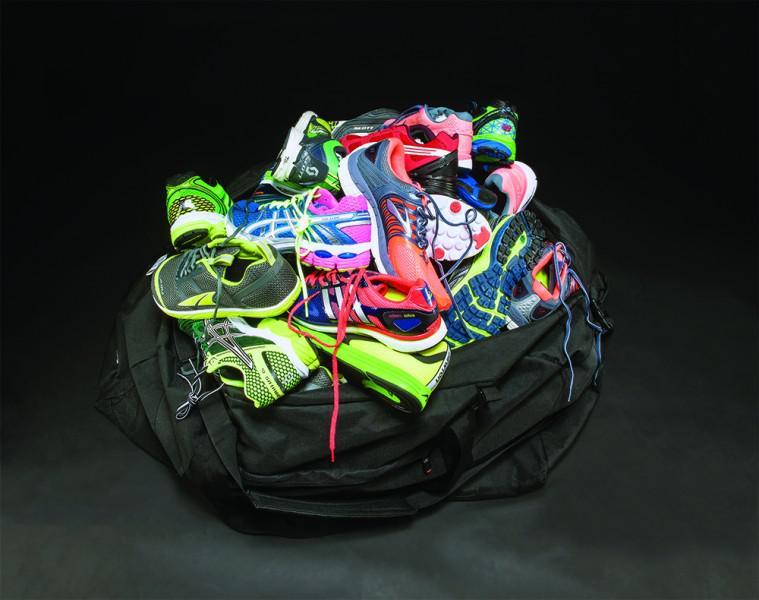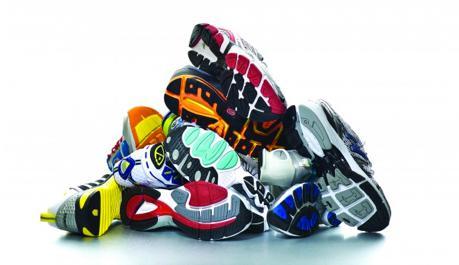The first image is the image on the left, the second image is the image on the right. For the images shown, is this caption "There is exactly one shoe in the image on the left." true? Answer yes or no. No. The first image is the image on the left, the second image is the image on the right. Considering the images on both sides, is "One image shows only one colorful shoe with matching laces." valid? Answer yes or no. No. 